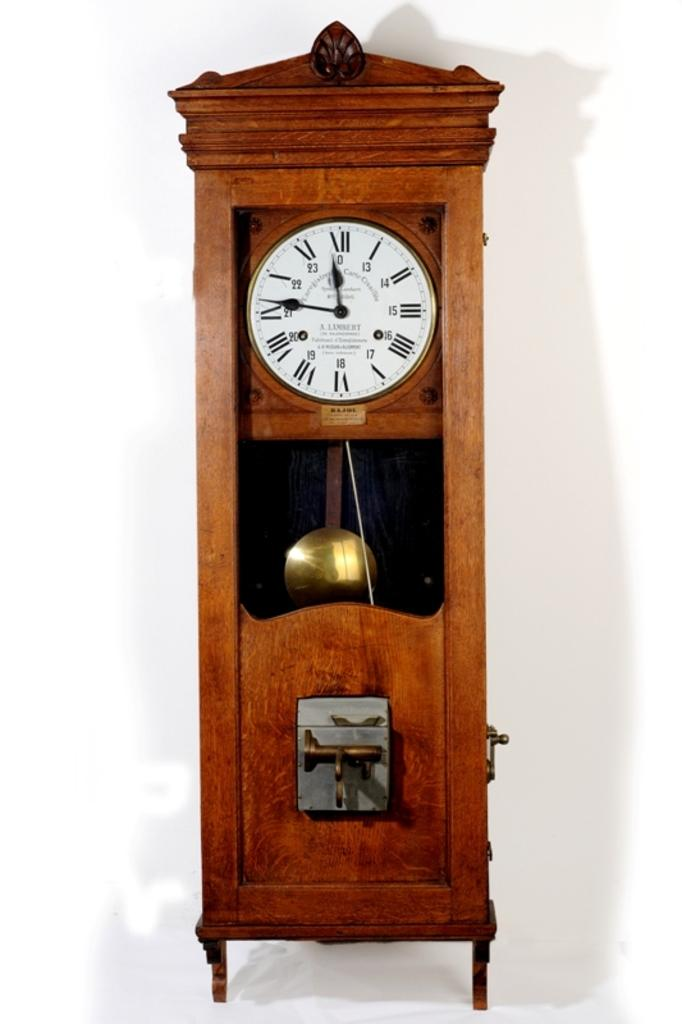<image>
Relay a brief, clear account of the picture shown. A grandfather clock has "A LAMBERT" on the face. 